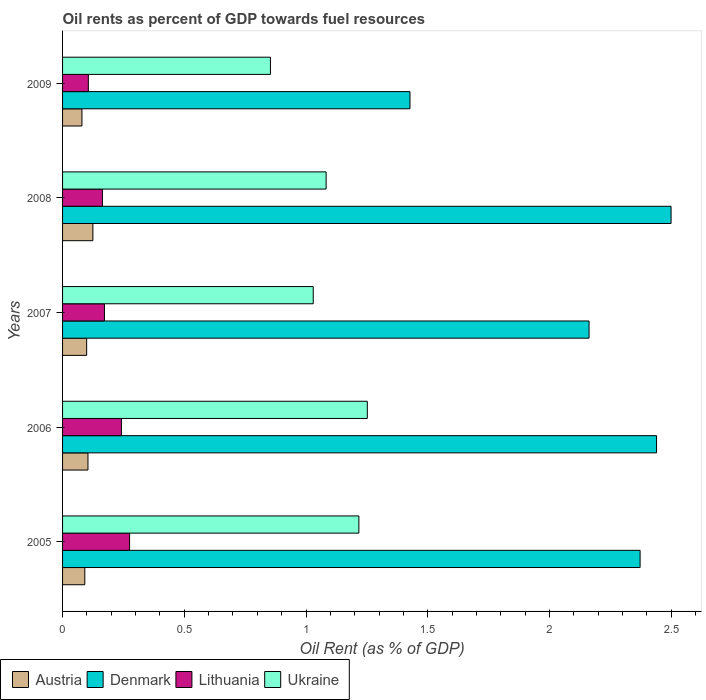How many different coloured bars are there?
Provide a short and direct response. 4. How many groups of bars are there?
Offer a terse response. 5. Are the number of bars on each tick of the Y-axis equal?
Ensure brevity in your answer.  Yes. How many bars are there on the 4th tick from the bottom?
Your answer should be very brief. 4. What is the label of the 3rd group of bars from the top?
Offer a very short reply. 2007. What is the oil rent in Ukraine in 2008?
Your answer should be very brief. 1.08. Across all years, what is the maximum oil rent in Lithuania?
Ensure brevity in your answer.  0.28. Across all years, what is the minimum oil rent in Lithuania?
Offer a very short reply. 0.11. In which year was the oil rent in Lithuania maximum?
Offer a very short reply. 2005. What is the total oil rent in Ukraine in the graph?
Keep it short and to the point. 5.44. What is the difference between the oil rent in Denmark in 2005 and that in 2009?
Provide a succinct answer. 0.95. What is the difference between the oil rent in Denmark in 2006 and the oil rent in Lithuania in 2007?
Offer a very short reply. 2.27. What is the average oil rent in Lithuania per year?
Ensure brevity in your answer.  0.19. In the year 2005, what is the difference between the oil rent in Lithuania and oil rent in Austria?
Keep it short and to the point. 0.18. In how many years, is the oil rent in Ukraine greater than 2.3 %?
Offer a very short reply. 0. What is the ratio of the oil rent in Lithuania in 2005 to that in 2006?
Your answer should be very brief. 1.14. Is the oil rent in Lithuania in 2007 less than that in 2009?
Offer a very short reply. No. Is the difference between the oil rent in Lithuania in 2008 and 2009 greater than the difference between the oil rent in Austria in 2008 and 2009?
Provide a short and direct response. Yes. What is the difference between the highest and the second highest oil rent in Ukraine?
Keep it short and to the point. 0.03. What is the difference between the highest and the lowest oil rent in Ukraine?
Ensure brevity in your answer.  0.4. In how many years, is the oil rent in Ukraine greater than the average oil rent in Ukraine taken over all years?
Provide a succinct answer. 2. Is it the case that in every year, the sum of the oil rent in Lithuania and oil rent in Austria is greater than the sum of oil rent in Ukraine and oil rent in Denmark?
Make the answer very short. No. What does the 4th bar from the top in 2008 represents?
Make the answer very short. Austria. What does the 3rd bar from the bottom in 2009 represents?
Your answer should be very brief. Lithuania. How many years are there in the graph?
Ensure brevity in your answer.  5. Where does the legend appear in the graph?
Offer a terse response. Bottom left. How many legend labels are there?
Your answer should be very brief. 4. What is the title of the graph?
Your answer should be compact. Oil rents as percent of GDP towards fuel resources. What is the label or title of the X-axis?
Your answer should be compact. Oil Rent (as % of GDP). What is the label or title of the Y-axis?
Your response must be concise. Years. What is the Oil Rent (as % of GDP) of Austria in 2005?
Keep it short and to the point. 0.09. What is the Oil Rent (as % of GDP) of Denmark in 2005?
Provide a short and direct response. 2.37. What is the Oil Rent (as % of GDP) in Lithuania in 2005?
Provide a succinct answer. 0.28. What is the Oil Rent (as % of GDP) of Ukraine in 2005?
Offer a terse response. 1.22. What is the Oil Rent (as % of GDP) of Austria in 2006?
Provide a short and direct response. 0.1. What is the Oil Rent (as % of GDP) of Denmark in 2006?
Provide a short and direct response. 2.44. What is the Oil Rent (as % of GDP) in Lithuania in 2006?
Keep it short and to the point. 0.24. What is the Oil Rent (as % of GDP) in Ukraine in 2006?
Your response must be concise. 1.25. What is the Oil Rent (as % of GDP) of Austria in 2007?
Your answer should be compact. 0.1. What is the Oil Rent (as % of GDP) in Denmark in 2007?
Your answer should be compact. 2.16. What is the Oil Rent (as % of GDP) in Lithuania in 2007?
Your response must be concise. 0.17. What is the Oil Rent (as % of GDP) of Ukraine in 2007?
Make the answer very short. 1.03. What is the Oil Rent (as % of GDP) of Austria in 2008?
Your response must be concise. 0.12. What is the Oil Rent (as % of GDP) in Denmark in 2008?
Provide a succinct answer. 2.5. What is the Oil Rent (as % of GDP) in Lithuania in 2008?
Give a very brief answer. 0.16. What is the Oil Rent (as % of GDP) in Ukraine in 2008?
Keep it short and to the point. 1.08. What is the Oil Rent (as % of GDP) of Austria in 2009?
Give a very brief answer. 0.08. What is the Oil Rent (as % of GDP) of Denmark in 2009?
Provide a succinct answer. 1.43. What is the Oil Rent (as % of GDP) in Lithuania in 2009?
Offer a very short reply. 0.11. What is the Oil Rent (as % of GDP) of Ukraine in 2009?
Your answer should be very brief. 0.85. Across all years, what is the maximum Oil Rent (as % of GDP) in Austria?
Your response must be concise. 0.12. Across all years, what is the maximum Oil Rent (as % of GDP) of Denmark?
Provide a succinct answer. 2.5. Across all years, what is the maximum Oil Rent (as % of GDP) in Lithuania?
Offer a very short reply. 0.28. Across all years, what is the maximum Oil Rent (as % of GDP) of Ukraine?
Your answer should be very brief. 1.25. Across all years, what is the minimum Oil Rent (as % of GDP) in Austria?
Give a very brief answer. 0.08. Across all years, what is the minimum Oil Rent (as % of GDP) in Denmark?
Provide a short and direct response. 1.43. Across all years, what is the minimum Oil Rent (as % of GDP) in Lithuania?
Your answer should be compact. 0.11. Across all years, what is the minimum Oil Rent (as % of GDP) of Ukraine?
Keep it short and to the point. 0.85. What is the total Oil Rent (as % of GDP) of Austria in the graph?
Provide a succinct answer. 0.5. What is the total Oil Rent (as % of GDP) in Denmark in the graph?
Your answer should be compact. 10.9. What is the total Oil Rent (as % of GDP) in Lithuania in the graph?
Give a very brief answer. 0.96. What is the total Oil Rent (as % of GDP) in Ukraine in the graph?
Your answer should be compact. 5.44. What is the difference between the Oil Rent (as % of GDP) of Austria in 2005 and that in 2006?
Provide a short and direct response. -0.01. What is the difference between the Oil Rent (as % of GDP) of Denmark in 2005 and that in 2006?
Ensure brevity in your answer.  -0.07. What is the difference between the Oil Rent (as % of GDP) in Lithuania in 2005 and that in 2006?
Keep it short and to the point. 0.03. What is the difference between the Oil Rent (as % of GDP) in Ukraine in 2005 and that in 2006?
Provide a succinct answer. -0.03. What is the difference between the Oil Rent (as % of GDP) in Austria in 2005 and that in 2007?
Your answer should be compact. -0.01. What is the difference between the Oil Rent (as % of GDP) in Denmark in 2005 and that in 2007?
Give a very brief answer. 0.21. What is the difference between the Oil Rent (as % of GDP) in Lithuania in 2005 and that in 2007?
Keep it short and to the point. 0.1. What is the difference between the Oil Rent (as % of GDP) of Ukraine in 2005 and that in 2007?
Your response must be concise. 0.19. What is the difference between the Oil Rent (as % of GDP) in Austria in 2005 and that in 2008?
Your response must be concise. -0.03. What is the difference between the Oil Rent (as % of GDP) in Denmark in 2005 and that in 2008?
Keep it short and to the point. -0.13. What is the difference between the Oil Rent (as % of GDP) in Lithuania in 2005 and that in 2008?
Your answer should be very brief. 0.11. What is the difference between the Oil Rent (as % of GDP) in Ukraine in 2005 and that in 2008?
Provide a short and direct response. 0.13. What is the difference between the Oil Rent (as % of GDP) in Austria in 2005 and that in 2009?
Offer a very short reply. 0.01. What is the difference between the Oil Rent (as % of GDP) in Denmark in 2005 and that in 2009?
Offer a very short reply. 0.95. What is the difference between the Oil Rent (as % of GDP) in Lithuania in 2005 and that in 2009?
Offer a terse response. 0.17. What is the difference between the Oil Rent (as % of GDP) of Ukraine in 2005 and that in 2009?
Offer a very short reply. 0.36. What is the difference between the Oil Rent (as % of GDP) in Austria in 2006 and that in 2007?
Your answer should be compact. 0.01. What is the difference between the Oil Rent (as % of GDP) in Denmark in 2006 and that in 2007?
Give a very brief answer. 0.28. What is the difference between the Oil Rent (as % of GDP) in Lithuania in 2006 and that in 2007?
Your response must be concise. 0.07. What is the difference between the Oil Rent (as % of GDP) of Ukraine in 2006 and that in 2007?
Your answer should be compact. 0.22. What is the difference between the Oil Rent (as % of GDP) of Austria in 2006 and that in 2008?
Offer a terse response. -0.02. What is the difference between the Oil Rent (as % of GDP) of Denmark in 2006 and that in 2008?
Offer a terse response. -0.06. What is the difference between the Oil Rent (as % of GDP) in Lithuania in 2006 and that in 2008?
Your answer should be compact. 0.08. What is the difference between the Oil Rent (as % of GDP) of Ukraine in 2006 and that in 2008?
Offer a terse response. 0.17. What is the difference between the Oil Rent (as % of GDP) of Austria in 2006 and that in 2009?
Offer a terse response. 0.02. What is the difference between the Oil Rent (as % of GDP) of Denmark in 2006 and that in 2009?
Make the answer very short. 1.01. What is the difference between the Oil Rent (as % of GDP) in Lithuania in 2006 and that in 2009?
Your answer should be compact. 0.14. What is the difference between the Oil Rent (as % of GDP) in Ukraine in 2006 and that in 2009?
Make the answer very short. 0.4. What is the difference between the Oil Rent (as % of GDP) of Austria in 2007 and that in 2008?
Provide a short and direct response. -0.03. What is the difference between the Oil Rent (as % of GDP) of Denmark in 2007 and that in 2008?
Provide a short and direct response. -0.34. What is the difference between the Oil Rent (as % of GDP) in Lithuania in 2007 and that in 2008?
Give a very brief answer. 0.01. What is the difference between the Oil Rent (as % of GDP) in Ukraine in 2007 and that in 2008?
Offer a very short reply. -0.05. What is the difference between the Oil Rent (as % of GDP) of Austria in 2007 and that in 2009?
Provide a succinct answer. 0.02. What is the difference between the Oil Rent (as % of GDP) of Denmark in 2007 and that in 2009?
Your answer should be very brief. 0.74. What is the difference between the Oil Rent (as % of GDP) in Lithuania in 2007 and that in 2009?
Ensure brevity in your answer.  0.07. What is the difference between the Oil Rent (as % of GDP) of Ukraine in 2007 and that in 2009?
Your answer should be very brief. 0.18. What is the difference between the Oil Rent (as % of GDP) in Austria in 2008 and that in 2009?
Offer a very short reply. 0.04. What is the difference between the Oil Rent (as % of GDP) in Denmark in 2008 and that in 2009?
Ensure brevity in your answer.  1.07. What is the difference between the Oil Rent (as % of GDP) of Lithuania in 2008 and that in 2009?
Give a very brief answer. 0.06. What is the difference between the Oil Rent (as % of GDP) in Ukraine in 2008 and that in 2009?
Your answer should be compact. 0.23. What is the difference between the Oil Rent (as % of GDP) of Austria in 2005 and the Oil Rent (as % of GDP) of Denmark in 2006?
Offer a very short reply. -2.35. What is the difference between the Oil Rent (as % of GDP) in Austria in 2005 and the Oil Rent (as % of GDP) in Lithuania in 2006?
Offer a very short reply. -0.15. What is the difference between the Oil Rent (as % of GDP) of Austria in 2005 and the Oil Rent (as % of GDP) of Ukraine in 2006?
Provide a succinct answer. -1.16. What is the difference between the Oil Rent (as % of GDP) of Denmark in 2005 and the Oil Rent (as % of GDP) of Lithuania in 2006?
Offer a very short reply. 2.13. What is the difference between the Oil Rent (as % of GDP) of Denmark in 2005 and the Oil Rent (as % of GDP) of Ukraine in 2006?
Offer a terse response. 1.12. What is the difference between the Oil Rent (as % of GDP) of Lithuania in 2005 and the Oil Rent (as % of GDP) of Ukraine in 2006?
Offer a very short reply. -0.98. What is the difference between the Oil Rent (as % of GDP) of Austria in 2005 and the Oil Rent (as % of GDP) of Denmark in 2007?
Your answer should be very brief. -2.07. What is the difference between the Oil Rent (as % of GDP) in Austria in 2005 and the Oil Rent (as % of GDP) in Lithuania in 2007?
Provide a succinct answer. -0.08. What is the difference between the Oil Rent (as % of GDP) of Austria in 2005 and the Oil Rent (as % of GDP) of Ukraine in 2007?
Keep it short and to the point. -0.94. What is the difference between the Oil Rent (as % of GDP) in Denmark in 2005 and the Oil Rent (as % of GDP) in Lithuania in 2007?
Your answer should be compact. 2.2. What is the difference between the Oil Rent (as % of GDP) in Denmark in 2005 and the Oil Rent (as % of GDP) in Ukraine in 2007?
Provide a short and direct response. 1.34. What is the difference between the Oil Rent (as % of GDP) of Lithuania in 2005 and the Oil Rent (as % of GDP) of Ukraine in 2007?
Offer a terse response. -0.75. What is the difference between the Oil Rent (as % of GDP) in Austria in 2005 and the Oil Rent (as % of GDP) in Denmark in 2008?
Your answer should be compact. -2.41. What is the difference between the Oil Rent (as % of GDP) in Austria in 2005 and the Oil Rent (as % of GDP) in Lithuania in 2008?
Ensure brevity in your answer.  -0.07. What is the difference between the Oil Rent (as % of GDP) of Austria in 2005 and the Oil Rent (as % of GDP) of Ukraine in 2008?
Offer a terse response. -0.99. What is the difference between the Oil Rent (as % of GDP) of Denmark in 2005 and the Oil Rent (as % of GDP) of Lithuania in 2008?
Give a very brief answer. 2.21. What is the difference between the Oil Rent (as % of GDP) of Denmark in 2005 and the Oil Rent (as % of GDP) of Ukraine in 2008?
Ensure brevity in your answer.  1.29. What is the difference between the Oil Rent (as % of GDP) of Lithuania in 2005 and the Oil Rent (as % of GDP) of Ukraine in 2008?
Offer a terse response. -0.81. What is the difference between the Oil Rent (as % of GDP) of Austria in 2005 and the Oil Rent (as % of GDP) of Denmark in 2009?
Provide a succinct answer. -1.34. What is the difference between the Oil Rent (as % of GDP) in Austria in 2005 and the Oil Rent (as % of GDP) in Lithuania in 2009?
Offer a terse response. -0.01. What is the difference between the Oil Rent (as % of GDP) of Austria in 2005 and the Oil Rent (as % of GDP) of Ukraine in 2009?
Ensure brevity in your answer.  -0.76. What is the difference between the Oil Rent (as % of GDP) in Denmark in 2005 and the Oil Rent (as % of GDP) in Lithuania in 2009?
Your answer should be compact. 2.27. What is the difference between the Oil Rent (as % of GDP) in Denmark in 2005 and the Oil Rent (as % of GDP) in Ukraine in 2009?
Give a very brief answer. 1.52. What is the difference between the Oil Rent (as % of GDP) of Lithuania in 2005 and the Oil Rent (as % of GDP) of Ukraine in 2009?
Give a very brief answer. -0.58. What is the difference between the Oil Rent (as % of GDP) in Austria in 2006 and the Oil Rent (as % of GDP) in Denmark in 2007?
Offer a very short reply. -2.06. What is the difference between the Oil Rent (as % of GDP) of Austria in 2006 and the Oil Rent (as % of GDP) of Lithuania in 2007?
Provide a succinct answer. -0.07. What is the difference between the Oil Rent (as % of GDP) of Austria in 2006 and the Oil Rent (as % of GDP) of Ukraine in 2007?
Give a very brief answer. -0.93. What is the difference between the Oil Rent (as % of GDP) of Denmark in 2006 and the Oil Rent (as % of GDP) of Lithuania in 2007?
Keep it short and to the point. 2.27. What is the difference between the Oil Rent (as % of GDP) in Denmark in 2006 and the Oil Rent (as % of GDP) in Ukraine in 2007?
Give a very brief answer. 1.41. What is the difference between the Oil Rent (as % of GDP) of Lithuania in 2006 and the Oil Rent (as % of GDP) of Ukraine in 2007?
Your answer should be very brief. -0.79. What is the difference between the Oil Rent (as % of GDP) of Austria in 2006 and the Oil Rent (as % of GDP) of Denmark in 2008?
Keep it short and to the point. -2.4. What is the difference between the Oil Rent (as % of GDP) of Austria in 2006 and the Oil Rent (as % of GDP) of Lithuania in 2008?
Ensure brevity in your answer.  -0.06. What is the difference between the Oil Rent (as % of GDP) of Austria in 2006 and the Oil Rent (as % of GDP) of Ukraine in 2008?
Ensure brevity in your answer.  -0.98. What is the difference between the Oil Rent (as % of GDP) in Denmark in 2006 and the Oil Rent (as % of GDP) in Lithuania in 2008?
Provide a succinct answer. 2.28. What is the difference between the Oil Rent (as % of GDP) in Denmark in 2006 and the Oil Rent (as % of GDP) in Ukraine in 2008?
Offer a terse response. 1.36. What is the difference between the Oil Rent (as % of GDP) in Lithuania in 2006 and the Oil Rent (as % of GDP) in Ukraine in 2008?
Your answer should be very brief. -0.84. What is the difference between the Oil Rent (as % of GDP) in Austria in 2006 and the Oil Rent (as % of GDP) in Denmark in 2009?
Provide a succinct answer. -1.32. What is the difference between the Oil Rent (as % of GDP) of Austria in 2006 and the Oil Rent (as % of GDP) of Lithuania in 2009?
Provide a succinct answer. -0. What is the difference between the Oil Rent (as % of GDP) in Austria in 2006 and the Oil Rent (as % of GDP) in Ukraine in 2009?
Provide a succinct answer. -0.75. What is the difference between the Oil Rent (as % of GDP) of Denmark in 2006 and the Oil Rent (as % of GDP) of Lithuania in 2009?
Your answer should be very brief. 2.33. What is the difference between the Oil Rent (as % of GDP) of Denmark in 2006 and the Oil Rent (as % of GDP) of Ukraine in 2009?
Provide a succinct answer. 1.59. What is the difference between the Oil Rent (as % of GDP) in Lithuania in 2006 and the Oil Rent (as % of GDP) in Ukraine in 2009?
Keep it short and to the point. -0.61. What is the difference between the Oil Rent (as % of GDP) in Austria in 2007 and the Oil Rent (as % of GDP) in Denmark in 2008?
Your response must be concise. -2.4. What is the difference between the Oil Rent (as % of GDP) of Austria in 2007 and the Oil Rent (as % of GDP) of Lithuania in 2008?
Give a very brief answer. -0.06. What is the difference between the Oil Rent (as % of GDP) of Austria in 2007 and the Oil Rent (as % of GDP) of Ukraine in 2008?
Provide a succinct answer. -0.98. What is the difference between the Oil Rent (as % of GDP) in Denmark in 2007 and the Oil Rent (as % of GDP) in Lithuania in 2008?
Provide a short and direct response. 2. What is the difference between the Oil Rent (as % of GDP) in Lithuania in 2007 and the Oil Rent (as % of GDP) in Ukraine in 2008?
Your response must be concise. -0.91. What is the difference between the Oil Rent (as % of GDP) in Austria in 2007 and the Oil Rent (as % of GDP) in Denmark in 2009?
Provide a succinct answer. -1.33. What is the difference between the Oil Rent (as % of GDP) of Austria in 2007 and the Oil Rent (as % of GDP) of Lithuania in 2009?
Keep it short and to the point. -0.01. What is the difference between the Oil Rent (as % of GDP) in Austria in 2007 and the Oil Rent (as % of GDP) in Ukraine in 2009?
Give a very brief answer. -0.75. What is the difference between the Oil Rent (as % of GDP) in Denmark in 2007 and the Oil Rent (as % of GDP) in Lithuania in 2009?
Offer a very short reply. 2.06. What is the difference between the Oil Rent (as % of GDP) of Denmark in 2007 and the Oil Rent (as % of GDP) of Ukraine in 2009?
Provide a short and direct response. 1.31. What is the difference between the Oil Rent (as % of GDP) in Lithuania in 2007 and the Oil Rent (as % of GDP) in Ukraine in 2009?
Keep it short and to the point. -0.68. What is the difference between the Oil Rent (as % of GDP) of Austria in 2008 and the Oil Rent (as % of GDP) of Denmark in 2009?
Offer a very short reply. -1.3. What is the difference between the Oil Rent (as % of GDP) of Austria in 2008 and the Oil Rent (as % of GDP) of Lithuania in 2009?
Your answer should be compact. 0.02. What is the difference between the Oil Rent (as % of GDP) of Austria in 2008 and the Oil Rent (as % of GDP) of Ukraine in 2009?
Offer a terse response. -0.73. What is the difference between the Oil Rent (as % of GDP) of Denmark in 2008 and the Oil Rent (as % of GDP) of Lithuania in 2009?
Offer a very short reply. 2.39. What is the difference between the Oil Rent (as % of GDP) of Denmark in 2008 and the Oil Rent (as % of GDP) of Ukraine in 2009?
Offer a terse response. 1.65. What is the difference between the Oil Rent (as % of GDP) of Lithuania in 2008 and the Oil Rent (as % of GDP) of Ukraine in 2009?
Make the answer very short. -0.69. What is the average Oil Rent (as % of GDP) in Austria per year?
Give a very brief answer. 0.1. What is the average Oil Rent (as % of GDP) in Denmark per year?
Your answer should be compact. 2.18. What is the average Oil Rent (as % of GDP) of Lithuania per year?
Give a very brief answer. 0.19. What is the average Oil Rent (as % of GDP) in Ukraine per year?
Your response must be concise. 1.09. In the year 2005, what is the difference between the Oil Rent (as % of GDP) of Austria and Oil Rent (as % of GDP) of Denmark?
Provide a short and direct response. -2.28. In the year 2005, what is the difference between the Oil Rent (as % of GDP) of Austria and Oil Rent (as % of GDP) of Lithuania?
Your response must be concise. -0.18. In the year 2005, what is the difference between the Oil Rent (as % of GDP) in Austria and Oil Rent (as % of GDP) in Ukraine?
Provide a short and direct response. -1.13. In the year 2005, what is the difference between the Oil Rent (as % of GDP) of Denmark and Oil Rent (as % of GDP) of Lithuania?
Your answer should be compact. 2.1. In the year 2005, what is the difference between the Oil Rent (as % of GDP) of Denmark and Oil Rent (as % of GDP) of Ukraine?
Offer a terse response. 1.16. In the year 2005, what is the difference between the Oil Rent (as % of GDP) in Lithuania and Oil Rent (as % of GDP) in Ukraine?
Provide a succinct answer. -0.94. In the year 2006, what is the difference between the Oil Rent (as % of GDP) in Austria and Oil Rent (as % of GDP) in Denmark?
Offer a terse response. -2.34. In the year 2006, what is the difference between the Oil Rent (as % of GDP) in Austria and Oil Rent (as % of GDP) in Lithuania?
Provide a succinct answer. -0.14. In the year 2006, what is the difference between the Oil Rent (as % of GDP) of Austria and Oil Rent (as % of GDP) of Ukraine?
Provide a short and direct response. -1.15. In the year 2006, what is the difference between the Oil Rent (as % of GDP) of Denmark and Oil Rent (as % of GDP) of Lithuania?
Ensure brevity in your answer.  2.2. In the year 2006, what is the difference between the Oil Rent (as % of GDP) of Denmark and Oil Rent (as % of GDP) of Ukraine?
Your answer should be compact. 1.19. In the year 2006, what is the difference between the Oil Rent (as % of GDP) of Lithuania and Oil Rent (as % of GDP) of Ukraine?
Provide a short and direct response. -1.01. In the year 2007, what is the difference between the Oil Rent (as % of GDP) in Austria and Oil Rent (as % of GDP) in Denmark?
Offer a terse response. -2.06. In the year 2007, what is the difference between the Oil Rent (as % of GDP) of Austria and Oil Rent (as % of GDP) of Lithuania?
Offer a very short reply. -0.07. In the year 2007, what is the difference between the Oil Rent (as % of GDP) in Austria and Oil Rent (as % of GDP) in Ukraine?
Provide a short and direct response. -0.93. In the year 2007, what is the difference between the Oil Rent (as % of GDP) of Denmark and Oil Rent (as % of GDP) of Lithuania?
Keep it short and to the point. 1.99. In the year 2007, what is the difference between the Oil Rent (as % of GDP) of Denmark and Oil Rent (as % of GDP) of Ukraine?
Ensure brevity in your answer.  1.13. In the year 2007, what is the difference between the Oil Rent (as % of GDP) in Lithuania and Oil Rent (as % of GDP) in Ukraine?
Your response must be concise. -0.86. In the year 2008, what is the difference between the Oil Rent (as % of GDP) in Austria and Oil Rent (as % of GDP) in Denmark?
Give a very brief answer. -2.38. In the year 2008, what is the difference between the Oil Rent (as % of GDP) in Austria and Oil Rent (as % of GDP) in Lithuania?
Your response must be concise. -0.04. In the year 2008, what is the difference between the Oil Rent (as % of GDP) of Austria and Oil Rent (as % of GDP) of Ukraine?
Your answer should be very brief. -0.96. In the year 2008, what is the difference between the Oil Rent (as % of GDP) in Denmark and Oil Rent (as % of GDP) in Lithuania?
Your response must be concise. 2.34. In the year 2008, what is the difference between the Oil Rent (as % of GDP) of Denmark and Oil Rent (as % of GDP) of Ukraine?
Make the answer very short. 1.42. In the year 2008, what is the difference between the Oil Rent (as % of GDP) of Lithuania and Oil Rent (as % of GDP) of Ukraine?
Make the answer very short. -0.92. In the year 2009, what is the difference between the Oil Rent (as % of GDP) of Austria and Oil Rent (as % of GDP) of Denmark?
Offer a very short reply. -1.35. In the year 2009, what is the difference between the Oil Rent (as % of GDP) of Austria and Oil Rent (as % of GDP) of Lithuania?
Provide a succinct answer. -0.03. In the year 2009, what is the difference between the Oil Rent (as % of GDP) of Austria and Oil Rent (as % of GDP) of Ukraine?
Your response must be concise. -0.77. In the year 2009, what is the difference between the Oil Rent (as % of GDP) of Denmark and Oil Rent (as % of GDP) of Lithuania?
Give a very brief answer. 1.32. In the year 2009, what is the difference between the Oil Rent (as % of GDP) in Denmark and Oil Rent (as % of GDP) in Ukraine?
Make the answer very short. 0.57. In the year 2009, what is the difference between the Oil Rent (as % of GDP) in Lithuania and Oil Rent (as % of GDP) in Ukraine?
Your answer should be compact. -0.75. What is the ratio of the Oil Rent (as % of GDP) of Austria in 2005 to that in 2006?
Keep it short and to the point. 0.88. What is the ratio of the Oil Rent (as % of GDP) in Denmark in 2005 to that in 2006?
Keep it short and to the point. 0.97. What is the ratio of the Oil Rent (as % of GDP) in Lithuania in 2005 to that in 2006?
Make the answer very short. 1.14. What is the ratio of the Oil Rent (as % of GDP) of Ukraine in 2005 to that in 2006?
Your answer should be compact. 0.97. What is the ratio of the Oil Rent (as % of GDP) in Austria in 2005 to that in 2007?
Provide a succinct answer. 0.92. What is the ratio of the Oil Rent (as % of GDP) in Denmark in 2005 to that in 2007?
Ensure brevity in your answer.  1.1. What is the ratio of the Oil Rent (as % of GDP) of Lithuania in 2005 to that in 2007?
Keep it short and to the point. 1.6. What is the ratio of the Oil Rent (as % of GDP) of Ukraine in 2005 to that in 2007?
Offer a very short reply. 1.18. What is the ratio of the Oil Rent (as % of GDP) in Austria in 2005 to that in 2008?
Offer a very short reply. 0.73. What is the ratio of the Oil Rent (as % of GDP) in Denmark in 2005 to that in 2008?
Provide a succinct answer. 0.95. What is the ratio of the Oil Rent (as % of GDP) in Lithuania in 2005 to that in 2008?
Offer a very short reply. 1.68. What is the ratio of the Oil Rent (as % of GDP) of Ukraine in 2005 to that in 2008?
Offer a terse response. 1.12. What is the ratio of the Oil Rent (as % of GDP) of Austria in 2005 to that in 2009?
Ensure brevity in your answer.  1.15. What is the ratio of the Oil Rent (as % of GDP) of Denmark in 2005 to that in 2009?
Offer a terse response. 1.66. What is the ratio of the Oil Rent (as % of GDP) of Lithuania in 2005 to that in 2009?
Your answer should be compact. 2.6. What is the ratio of the Oil Rent (as % of GDP) in Ukraine in 2005 to that in 2009?
Make the answer very short. 1.43. What is the ratio of the Oil Rent (as % of GDP) of Austria in 2006 to that in 2007?
Provide a short and direct response. 1.05. What is the ratio of the Oil Rent (as % of GDP) in Denmark in 2006 to that in 2007?
Your response must be concise. 1.13. What is the ratio of the Oil Rent (as % of GDP) in Lithuania in 2006 to that in 2007?
Your response must be concise. 1.41. What is the ratio of the Oil Rent (as % of GDP) of Ukraine in 2006 to that in 2007?
Your answer should be very brief. 1.22. What is the ratio of the Oil Rent (as % of GDP) of Austria in 2006 to that in 2008?
Your answer should be very brief. 0.84. What is the ratio of the Oil Rent (as % of GDP) in Denmark in 2006 to that in 2008?
Offer a terse response. 0.98. What is the ratio of the Oil Rent (as % of GDP) in Lithuania in 2006 to that in 2008?
Keep it short and to the point. 1.48. What is the ratio of the Oil Rent (as % of GDP) in Ukraine in 2006 to that in 2008?
Provide a short and direct response. 1.16. What is the ratio of the Oil Rent (as % of GDP) in Austria in 2006 to that in 2009?
Keep it short and to the point. 1.31. What is the ratio of the Oil Rent (as % of GDP) of Denmark in 2006 to that in 2009?
Provide a short and direct response. 1.71. What is the ratio of the Oil Rent (as % of GDP) of Lithuania in 2006 to that in 2009?
Make the answer very short. 2.28. What is the ratio of the Oil Rent (as % of GDP) of Ukraine in 2006 to that in 2009?
Provide a succinct answer. 1.47. What is the ratio of the Oil Rent (as % of GDP) in Austria in 2007 to that in 2008?
Offer a very short reply. 0.79. What is the ratio of the Oil Rent (as % of GDP) in Denmark in 2007 to that in 2008?
Provide a short and direct response. 0.87. What is the ratio of the Oil Rent (as % of GDP) in Lithuania in 2007 to that in 2008?
Your response must be concise. 1.05. What is the ratio of the Oil Rent (as % of GDP) in Ukraine in 2007 to that in 2008?
Offer a very short reply. 0.95. What is the ratio of the Oil Rent (as % of GDP) in Austria in 2007 to that in 2009?
Keep it short and to the point. 1.24. What is the ratio of the Oil Rent (as % of GDP) in Denmark in 2007 to that in 2009?
Ensure brevity in your answer.  1.52. What is the ratio of the Oil Rent (as % of GDP) in Lithuania in 2007 to that in 2009?
Keep it short and to the point. 1.63. What is the ratio of the Oil Rent (as % of GDP) of Ukraine in 2007 to that in 2009?
Provide a succinct answer. 1.21. What is the ratio of the Oil Rent (as % of GDP) in Austria in 2008 to that in 2009?
Your answer should be very brief. 1.57. What is the ratio of the Oil Rent (as % of GDP) of Denmark in 2008 to that in 2009?
Give a very brief answer. 1.75. What is the ratio of the Oil Rent (as % of GDP) in Lithuania in 2008 to that in 2009?
Offer a terse response. 1.55. What is the ratio of the Oil Rent (as % of GDP) of Ukraine in 2008 to that in 2009?
Make the answer very short. 1.27. What is the difference between the highest and the second highest Oil Rent (as % of GDP) in Austria?
Ensure brevity in your answer.  0.02. What is the difference between the highest and the second highest Oil Rent (as % of GDP) in Denmark?
Your response must be concise. 0.06. What is the difference between the highest and the second highest Oil Rent (as % of GDP) in Lithuania?
Give a very brief answer. 0.03. What is the difference between the highest and the second highest Oil Rent (as % of GDP) in Ukraine?
Your answer should be compact. 0.03. What is the difference between the highest and the lowest Oil Rent (as % of GDP) in Austria?
Give a very brief answer. 0.04. What is the difference between the highest and the lowest Oil Rent (as % of GDP) in Denmark?
Keep it short and to the point. 1.07. What is the difference between the highest and the lowest Oil Rent (as % of GDP) in Lithuania?
Offer a terse response. 0.17. What is the difference between the highest and the lowest Oil Rent (as % of GDP) of Ukraine?
Provide a succinct answer. 0.4. 